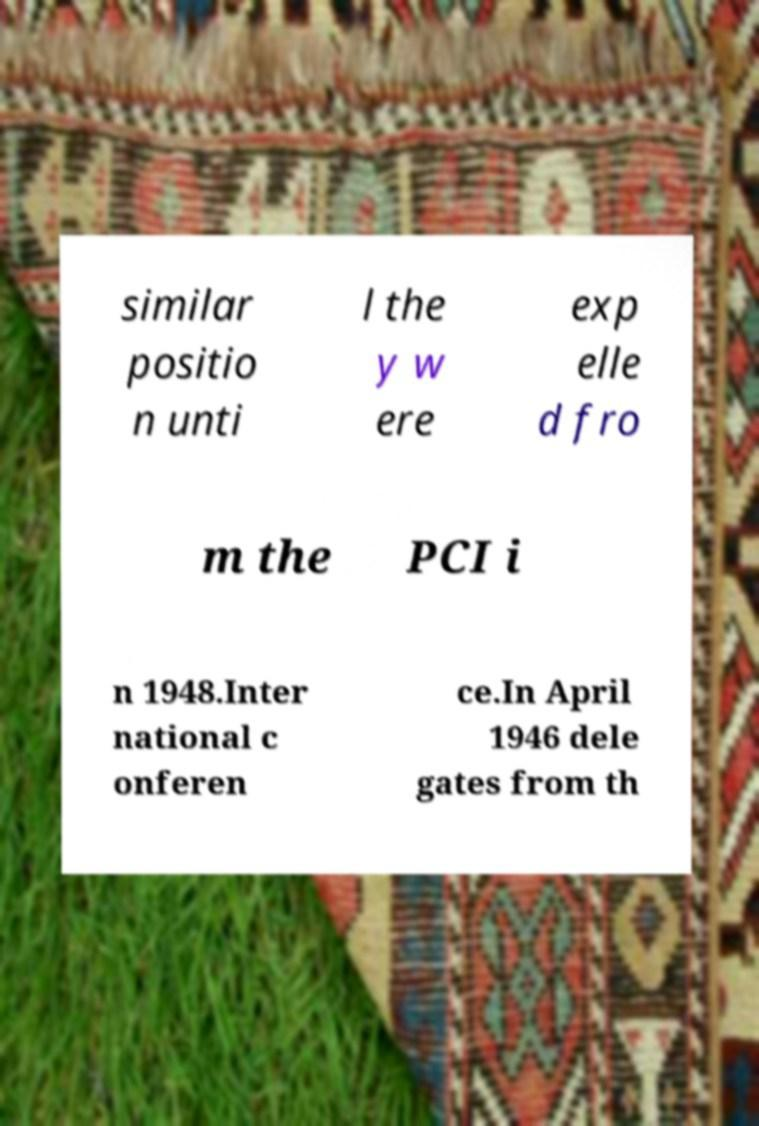There's text embedded in this image that I need extracted. Can you transcribe it verbatim? similar positio n unti l the y w ere exp elle d fro m the PCI i n 1948.Inter national c onferen ce.In April 1946 dele gates from th 